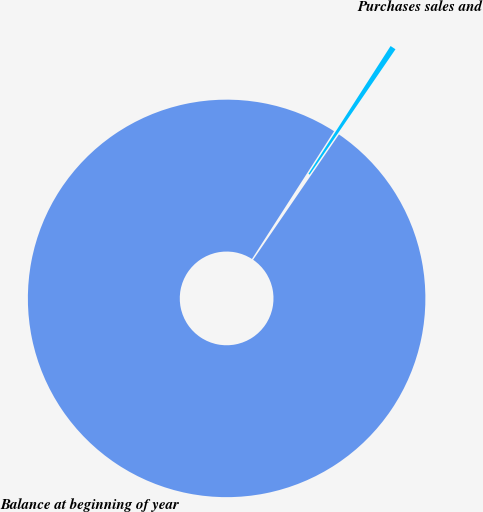<chart> <loc_0><loc_0><loc_500><loc_500><pie_chart><fcel>Balance at beginning of year<fcel>Purchases sales and<nl><fcel>99.53%<fcel>0.47%<nl></chart> 